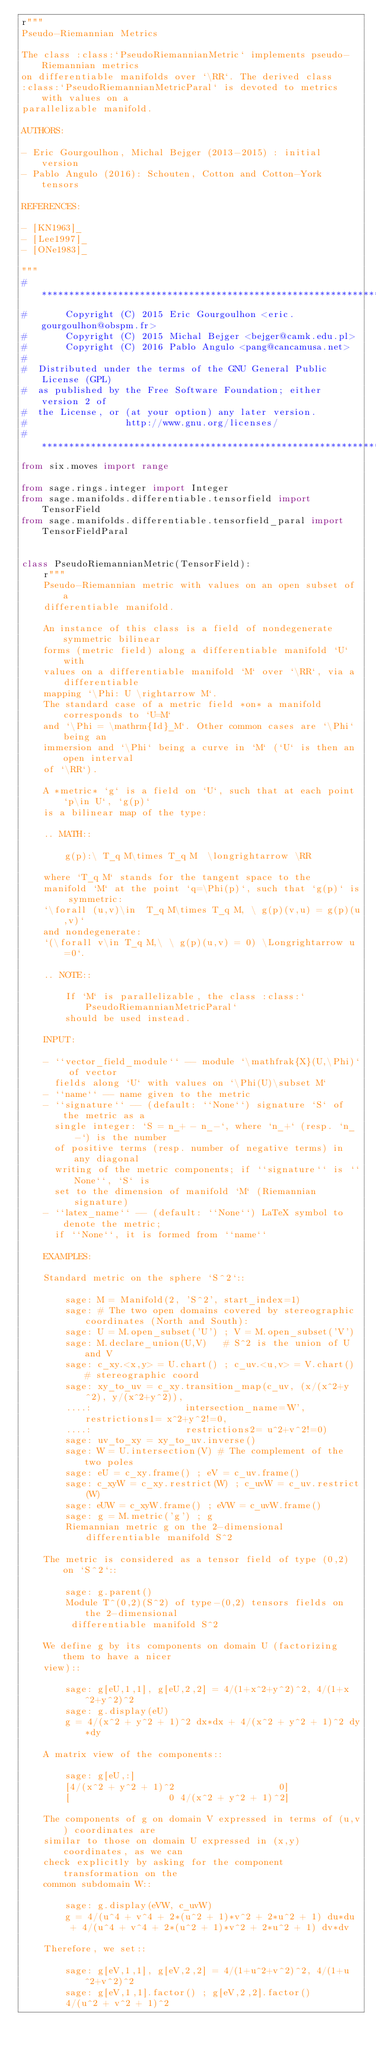Convert code to text. <code><loc_0><loc_0><loc_500><loc_500><_Python_>r"""
Pseudo-Riemannian Metrics

The class :class:`PseudoRiemannianMetric` implements pseudo-Riemannian metrics
on differentiable manifolds over `\RR`. The derived class
:class:`PseudoRiemannianMetricParal` is devoted to metrics with values on a
parallelizable manifold.

AUTHORS:

- Eric Gourgoulhon, Michal Bejger (2013-2015) : initial version
- Pablo Angulo (2016): Schouten, Cotton and Cotton-York tensors

REFERENCES:

- [KN1963]_
- [Lee1997]_
- [ONe1983]_

"""
#******************************************************************************
#       Copyright (C) 2015 Eric Gourgoulhon <eric.gourgoulhon@obspm.fr>
#       Copyright (C) 2015 Michal Bejger <bejger@camk.edu.pl>
#       Copyright (C) 2016 Pablo Angulo <pang@cancamusa.net>
#
#  Distributed under the terms of the GNU General Public License (GPL)
#  as published by the Free Software Foundation; either version 2 of
#  the License, or (at your option) any later version.
#                  http://www.gnu.org/licenses/
#******************************************************************************
from six.moves import range

from sage.rings.integer import Integer
from sage.manifolds.differentiable.tensorfield import TensorField
from sage.manifolds.differentiable.tensorfield_paral import TensorFieldParal


class PseudoRiemannianMetric(TensorField):
    r"""
    Pseudo-Riemannian metric with values on an open subset of a
    differentiable manifold.

    An instance of this class is a field of nondegenerate symmetric bilinear
    forms (metric field) along a differentiable manifold `U` with
    values on a differentiable manifold `M` over `\RR`, via a differentiable
    mapping `\Phi: U \rightarrow M`.
    The standard case of a metric field *on* a manifold corresponds to `U=M`
    and `\Phi = \mathrm{Id}_M`. Other common cases are `\Phi` being an
    immersion and `\Phi` being a curve in `M` (`U` is then an open interval
    of `\RR`).

    A *metric* `g` is a field on `U`, such that at each point `p\in U`, `g(p)`
    is a bilinear map of the type:

    .. MATH::

        g(p):\ T_q M\times T_q M  \longrightarrow \RR

    where `T_q M` stands for the tangent space to the
    manifold `M` at the point `q=\Phi(p)`, such that `g(p)` is symmetric:
    `\forall (u,v)\in  T_q M\times T_q M, \ g(p)(v,u) = g(p)(u,v)`
    and nondegenerate:
    `(\forall v\in T_q M,\ \ g(p)(u,v) = 0) \Longrightarrow u=0`.

    .. NOTE::

        If `M` is parallelizable, the class :class:`PseudoRiemannianMetricParal`
        should be used instead.

    INPUT:

    - ``vector_field_module`` -- module `\mathfrak{X}(U,\Phi)` of vector
      fields along `U` with values on `\Phi(U)\subset M`
    - ``name`` -- name given to the metric
    - ``signature`` -- (default: ``None``) signature `S` of the metric as a
      single integer: `S = n_+ - n_-`, where `n_+` (resp. `n_-`) is the number
      of positive terms (resp. number of negative terms) in any diagonal
      writing of the metric components; if ``signature`` is ``None``, `S` is
      set to the dimension of manifold `M` (Riemannian signature)
    - ``latex_name`` -- (default: ``None``) LaTeX symbol to denote the metric;
      if ``None``, it is formed from ``name``

    EXAMPLES:

    Standard metric on the sphere `S^2`::

        sage: M = Manifold(2, 'S^2', start_index=1)
        sage: # The two open domains covered by stereographic coordinates (North and South):
        sage: U = M.open_subset('U') ; V = M.open_subset('V')
        sage: M.declare_union(U,V)   # S^2 is the union of U and V
        sage: c_xy.<x,y> = U.chart() ; c_uv.<u,v> = V.chart() # stereographic coord
        sage: xy_to_uv = c_xy.transition_map(c_uv, (x/(x^2+y^2), y/(x^2+y^2)),
        ....:                 intersection_name='W', restrictions1= x^2+y^2!=0,
        ....:                 restrictions2= u^2+v^2!=0)
        sage: uv_to_xy = xy_to_uv.inverse()
        sage: W = U.intersection(V) # The complement of the two poles
        sage: eU = c_xy.frame() ; eV = c_uv.frame()
        sage: c_xyW = c_xy.restrict(W) ; c_uvW = c_uv.restrict(W)
        sage: eUW = c_xyW.frame() ; eVW = c_uvW.frame()
        sage: g = M.metric('g') ; g
        Riemannian metric g on the 2-dimensional differentiable manifold S^2

    The metric is considered as a tensor field of type (0,2) on `S^2`::

        sage: g.parent()
        Module T^(0,2)(S^2) of type-(0,2) tensors fields on the 2-dimensional
         differentiable manifold S^2

    We define g by its components on domain U (factorizing them to have a nicer
    view)::

        sage: g[eU,1,1], g[eU,2,2] = 4/(1+x^2+y^2)^2, 4/(1+x^2+y^2)^2
        sage: g.display(eU)
        g = 4/(x^2 + y^2 + 1)^2 dx*dx + 4/(x^2 + y^2 + 1)^2 dy*dy

    A matrix view of the components::

        sage: g[eU,:]
        [4/(x^2 + y^2 + 1)^2                   0]
        [                  0 4/(x^2 + y^2 + 1)^2]

    The components of g on domain V expressed in terms of (u,v) coordinates are
    similar to those on domain U expressed in (x,y) coordinates, as we can
    check explicitly by asking for the component transformation on the
    common subdomain W::

        sage: g.display(eVW, c_uvW)
        g = 4/(u^4 + v^4 + 2*(u^2 + 1)*v^2 + 2*u^2 + 1) du*du
         + 4/(u^4 + v^4 + 2*(u^2 + 1)*v^2 + 2*u^2 + 1) dv*dv

    Therefore, we set::

        sage: g[eV,1,1], g[eV,2,2] = 4/(1+u^2+v^2)^2, 4/(1+u^2+v^2)^2
        sage: g[eV,1,1].factor() ; g[eV,2,2].factor()
        4/(u^2 + v^2 + 1)^2</code> 